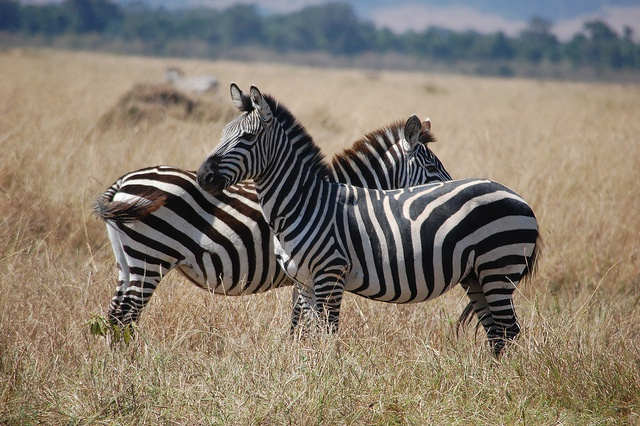Describe the objects in this image and their specific colors. I can see zebra in darkblue, black, gray, darkgray, and lightgray tones, zebra in darkblue, black, gray, darkgray, and lightgray tones, and zebra in darkblue, darkgray, gray, and lightgray tones in this image. 